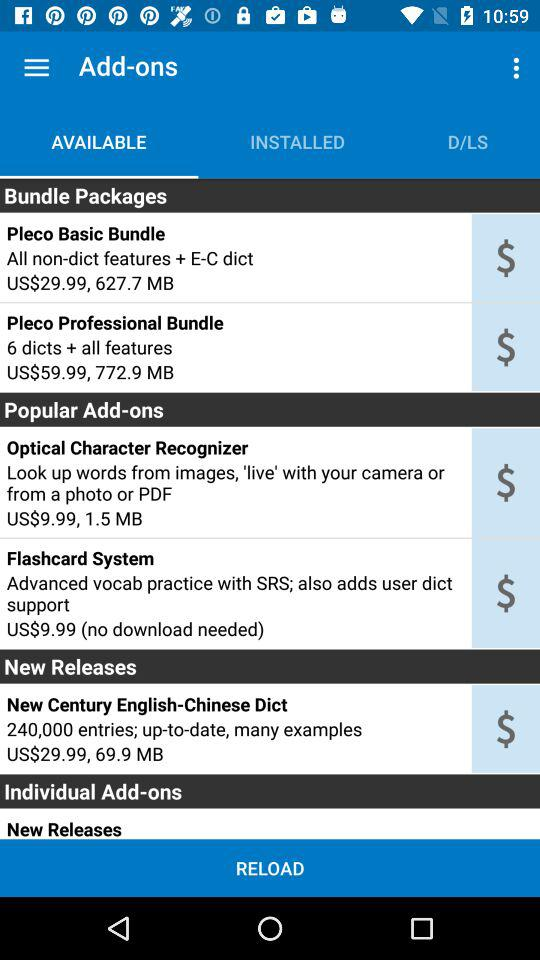How many bundle packages are available?
Answer the question using a single word or phrase. 2 